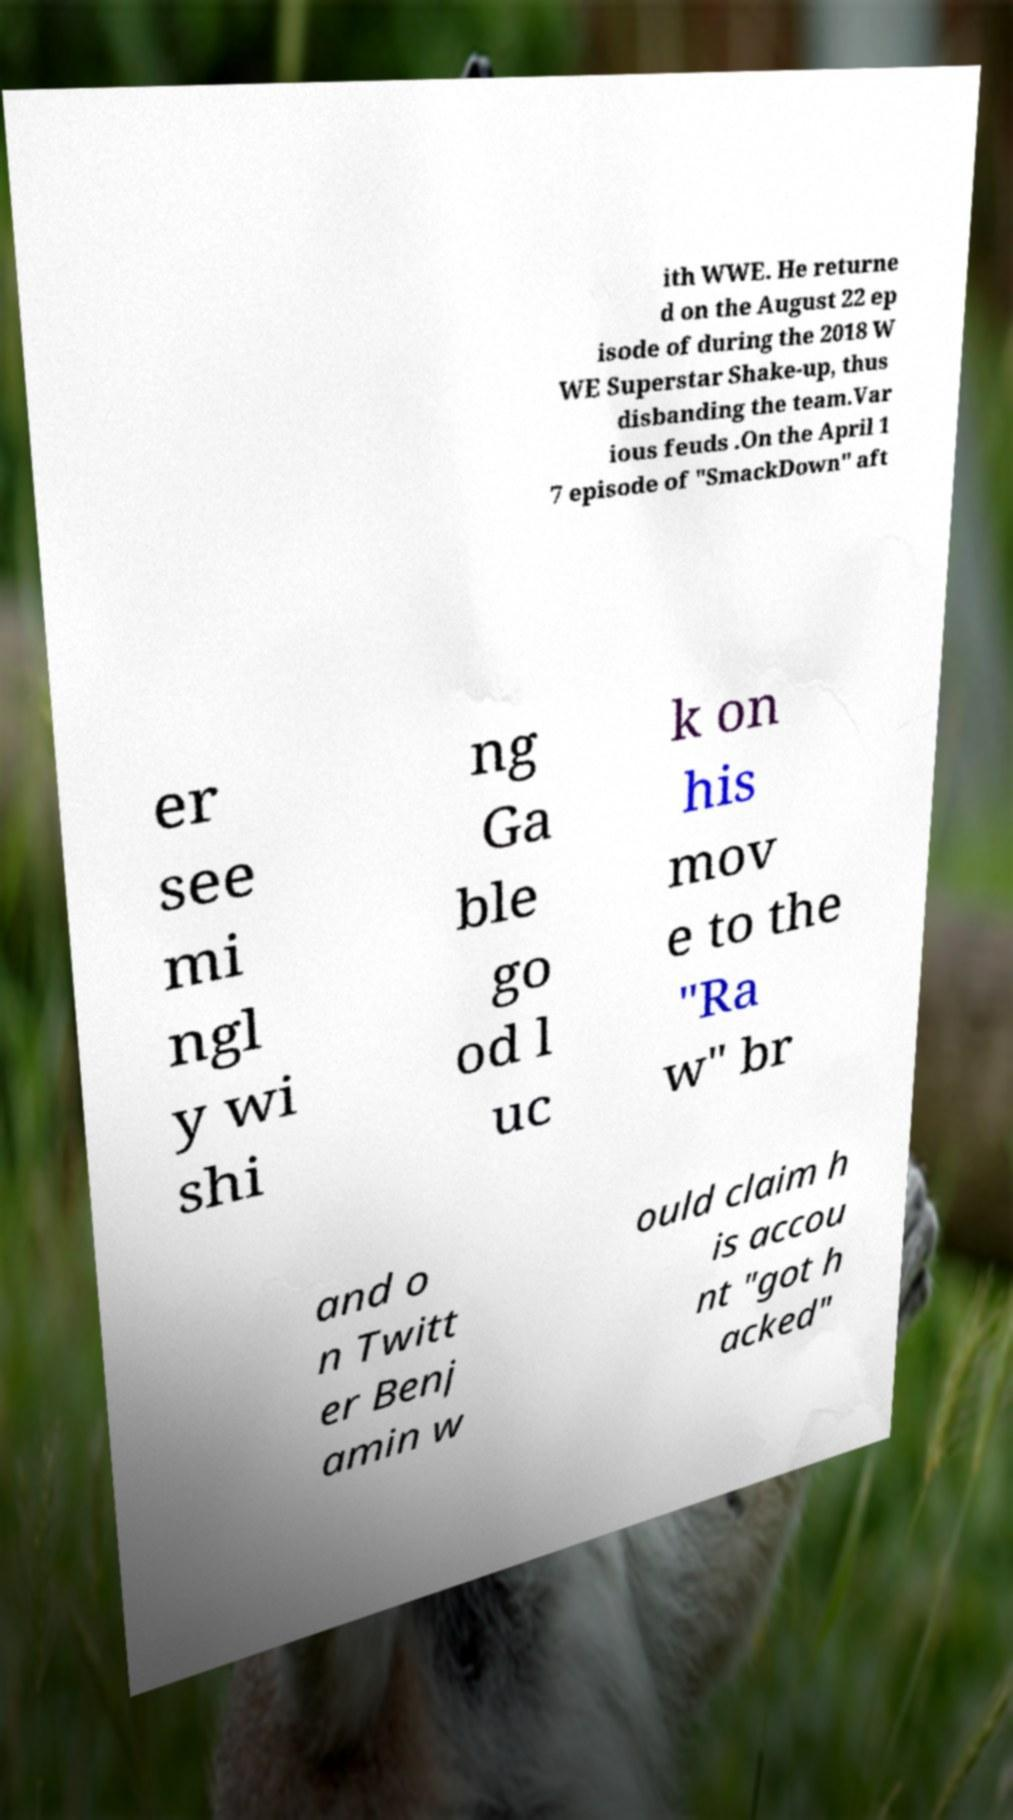Can you accurately transcribe the text from the provided image for me? ith WWE. He returne d on the August 22 ep isode of during the 2018 W WE Superstar Shake-up, thus disbanding the team.Var ious feuds .On the April 1 7 episode of "SmackDown" aft er see mi ngl y wi shi ng Ga ble go od l uc k on his mov e to the "Ra w" br and o n Twitt er Benj amin w ould claim h is accou nt "got h acked" 